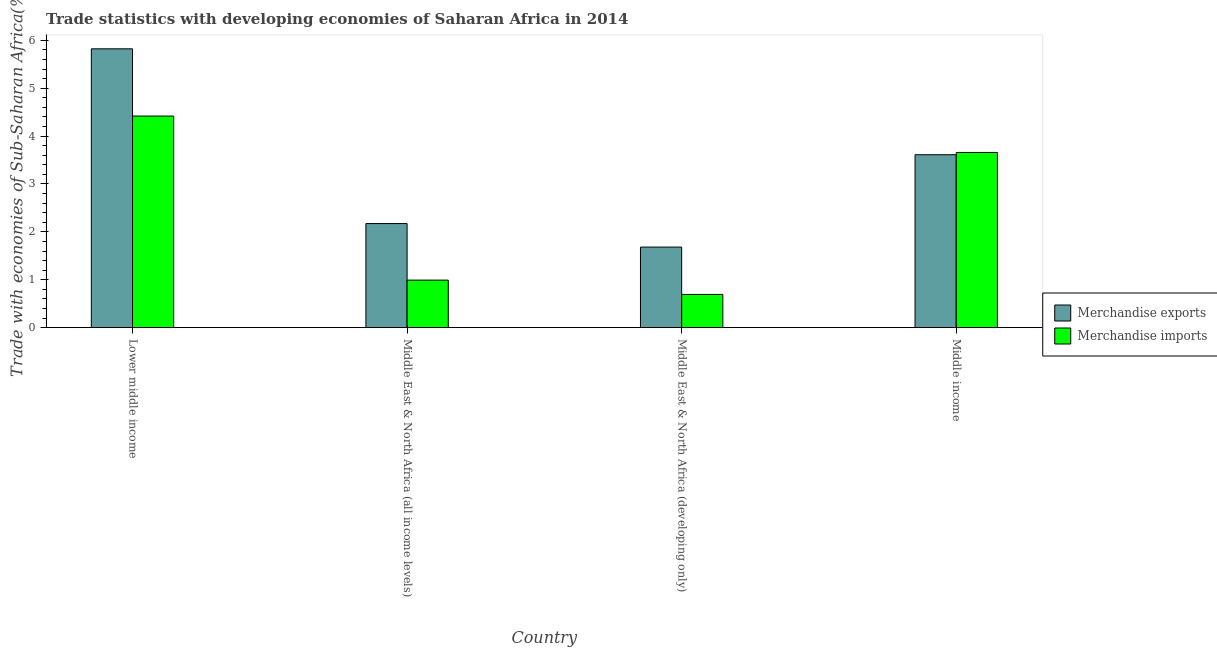How many different coloured bars are there?
Your response must be concise. 2. Are the number of bars per tick equal to the number of legend labels?
Ensure brevity in your answer.  Yes. How many bars are there on the 4th tick from the left?
Provide a short and direct response. 2. How many bars are there on the 4th tick from the right?
Keep it short and to the point. 2. What is the label of the 3rd group of bars from the left?
Your answer should be very brief. Middle East & North Africa (developing only). What is the merchandise exports in Middle income?
Your answer should be compact. 3.61. Across all countries, what is the maximum merchandise imports?
Make the answer very short. 4.42. Across all countries, what is the minimum merchandise imports?
Provide a succinct answer. 0.69. In which country was the merchandise imports maximum?
Your answer should be very brief. Lower middle income. In which country was the merchandise imports minimum?
Keep it short and to the point. Middle East & North Africa (developing only). What is the total merchandise exports in the graph?
Your answer should be compact. 13.29. What is the difference between the merchandise imports in Middle East & North Africa (all income levels) and that in Middle East & North Africa (developing only)?
Your response must be concise. 0.3. What is the difference between the merchandise exports in Lower middle income and the merchandise imports in Middle East & North Africa (developing only)?
Your answer should be very brief. 5.13. What is the average merchandise imports per country?
Offer a terse response. 2.44. What is the difference between the merchandise imports and merchandise exports in Middle East & North Africa (developing only)?
Make the answer very short. -0.99. In how many countries, is the merchandise exports greater than 0.2 %?
Provide a succinct answer. 4. What is the ratio of the merchandise imports in Middle East & North Africa (all income levels) to that in Middle East & North Africa (developing only)?
Offer a terse response. 1.43. What is the difference between the highest and the second highest merchandise imports?
Keep it short and to the point. 0.76. What is the difference between the highest and the lowest merchandise imports?
Offer a very short reply. 3.72. What does the 2nd bar from the left in Middle East & North Africa (developing only) represents?
Your answer should be very brief. Merchandise imports. What does the 2nd bar from the right in Middle East & North Africa (all income levels) represents?
Your response must be concise. Merchandise exports. How many bars are there?
Your answer should be compact. 8. Are all the bars in the graph horizontal?
Ensure brevity in your answer.  No. How many countries are there in the graph?
Give a very brief answer. 4. What is the difference between two consecutive major ticks on the Y-axis?
Provide a short and direct response. 1. Does the graph contain any zero values?
Your answer should be compact. No. Does the graph contain grids?
Make the answer very short. No. Where does the legend appear in the graph?
Ensure brevity in your answer.  Center right. How many legend labels are there?
Give a very brief answer. 2. How are the legend labels stacked?
Offer a terse response. Vertical. What is the title of the graph?
Give a very brief answer. Trade statistics with developing economies of Saharan Africa in 2014. Does "Fraud firms" appear as one of the legend labels in the graph?
Give a very brief answer. No. What is the label or title of the Y-axis?
Keep it short and to the point. Trade with economies of Sub-Saharan Africa(%). What is the Trade with economies of Sub-Saharan Africa(%) in Merchandise exports in Lower middle income?
Provide a short and direct response. 5.82. What is the Trade with economies of Sub-Saharan Africa(%) in Merchandise imports in Lower middle income?
Your response must be concise. 4.42. What is the Trade with economies of Sub-Saharan Africa(%) of Merchandise exports in Middle East & North Africa (all income levels)?
Offer a very short reply. 2.17. What is the Trade with economies of Sub-Saharan Africa(%) of Merchandise imports in Middle East & North Africa (all income levels)?
Provide a short and direct response. 0.99. What is the Trade with economies of Sub-Saharan Africa(%) in Merchandise exports in Middle East & North Africa (developing only)?
Offer a terse response. 1.68. What is the Trade with economies of Sub-Saharan Africa(%) in Merchandise imports in Middle East & North Africa (developing only)?
Your answer should be very brief. 0.69. What is the Trade with economies of Sub-Saharan Africa(%) of Merchandise exports in Middle income?
Offer a very short reply. 3.61. What is the Trade with economies of Sub-Saharan Africa(%) in Merchandise imports in Middle income?
Give a very brief answer. 3.66. Across all countries, what is the maximum Trade with economies of Sub-Saharan Africa(%) in Merchandise exports?
Your answer should be compact. 5.82. Across all countries, what is the maximum Trade with economies of Sub-Saharan Africa(%) in Merchandise imports?
Make the answer very short. 4.42. Across all countries, what is the minimum Trade with economies of Sub-Saharan Africa(%) in Merchandise exports?
Ensure brevity in your answer.  1.68. Across all countries, what is the minimum Trade with economies of Sub-Saharan Africa(%) of Merchandise imports?
Provide a succinct answer. 0.69. What is the total Trade with economies of Sub-Saharan Africa(%) of Merchandise exports in the graph?
Offer a very short reply. 13.29. What is the total Trade with economies of Sub-Saharan Africa(%) of Merchandise imports in the graph?
Your answer should be compact. 9.76. What is the difference between the Trade with economies of Sub-Saharan Africa(%) in Merchandise exports in Lower middle income and that in Middle East & North Africa (all income levels)?
Give a very brief answer. 3.65. What is the difference between the Trade with economies of Sub-Saharan Africa(%) of Merchandise imports in Lower middle income and that in Middle East & North Africa (all income levels)?
Provide a succinct answer. 3.43. What is the difference between the Trade with economies of Sub-Saharan Africa(%) in Merchandise exports in Lower middle income and that in Middle East & North Africa (developing only)?
Offer a terse response. 4.14. What is the difference between the Trade with economies of Sub-Saharan Africa(%) in Merchandise imports in Lower middle income and that in Middle East & North Africa (developing only)?
Offer a terse response. 3.72. What is the difference between the Trade with economies of Sub-Saharan Africa(%) in Merchandise exports in Lower middle income and that in Middle income?
Ensure brevity in your answer.  2.21. What is the difference between the Trade with economies of Sub-Saharan Africa(%) in Merchandise imports in Lower middle income and that in Middle income?
Provide a short and direct response. 0.76. What is the difference between the Trade with economies of Sub-Saharan Africa(%) of Merchandise exports in Middle East & North Africa (all income levels) and that in Middle East & North Africa (developing only)?
Provide a succinct answer. 0.49. What is the difference between the Trade with economies of Sub-Saharan Africa(%) of Merchandise imports in Middle East & North Africa (all income levels) and that in Middle East & North Africa (developing only)?
Offer a very short reply. 0.3. What is the difference between the Trade with economies of Sub-Saharan Africa(%) in Merchandise exports in Middle East & North Africa (all income levels) and that in Middle income?
Give a very brief answer. -1.44. What is the difference between the Trade with economies of Sub-Saharan Africa(%) in Merchandise imports in Middle East & North Africa (all income levels) and that in Middle income?
Ensure brevity in your answer.  -2.67. What is the difference between the Trade with economies of Sub-Saharan Africa(%) of Merchandise exports in Middle East & North Africa (developing only) and that in Middle income?
Offer a very short reply. -1.93. What is the difference between the Trade with economies of Sub-Saharan Africa(%) of Merchandise imports in Middle East & North Africa (developing only) and that in Middle income?
Make the answer very short. -2.96. What is the difference between the Trade with economies of Sub-Saharan Africa(%) of Merchandise exports in Lower middle income and the Trade with economies of Sub-Saharan Africa(%) of Merchandise imports in Middle East & North Africa (all income levels)?
Give a very brief answer. 4.83. What is the difference between the Trade with economies of Sub-Saharan Africa(%) of Merchandise exports in Lower middle income and the Trade with economies of Sub-Saharan Africa(%) of Merchandise imports in Middle East & North Africa (developing only)?
Provide a short and direct response. 5.13. What is the difference between the Trade with economies of Sub-Saharan Africa(%) in Merchandise exports in Lower middle income and the Trade with economies of Sub-Saharan Africa(%) in Merchandise imports in Middle income?
Keep it short and to the point. 2.16. What is the difference between the Trade with economies of Sub-Saharan Africa(%) in Merchandise exports in Middle East & North Africa (all income levels) and the Trade with economies of Sub-Saharan Africa(%) in Merchandise imports in Middle East & North Africa (developing only)?
Keep it short and to the point. 1.48. What is the difference between the Trade with economies of Sub-Saharan Africa(%) of Merchandise exports in Middle East & North Africa (all income levels) and the Trade with economies of Sub-Saharan Africa(%) of Merchandise imports in Middle income?
Your answer should be compact. -1.48. What is the difference between the Trade with economies of Sub-Saharan Africa(%) in Merchandise exports in Middle East & North Africa (developing only) and the Trade with economies of Sub-Saharan Africa(%) in Merchandise imports in Middle income?
Your response must be concise. -1.98. What is the average Trade with economies of Sub-Saharan Africa(%) in Merchandise exports per country?
Offer a terse response. 3.32. What is the average Trade with economies of Sub-Saharan Africa(%) in Merchandise imports per country?
Make the answer very short. 2.44. What is the difference between the Trade with economies of Sub-Saharan Africa(%) in Merchandise exports and Trade with economies of Sub-Saharan Africa(%) in Merchandise imports in Lower middle income?
Your response must be concise. 1.4. What is the difference between the Trade with economies of Sub-Saharan Africa(%) of Merchandise exports and Trade with economies of Sub-Saharan Africa(%) of Merchandise imports in Middle East & North Africa (all income levels)?
Your answer should be very brief. 1.18. What is the difference between the Trade with economies of Sub-Saharan Africa(%) in Merchandise exports and Trade with economies of Sub-Saharan Africa(%) in Merchandise imports in Middle East & North Africa (developing only)?
Offer a very short reply. 0.99. What is the difference between the Trade with economies of Sub-Saharan Africa(%) of Merchandise exports and Trade with economies of Sub-Saharan Africa(%) of Merchandise imports in Middle income?
Provide a short and direct response. -0.05. What is the ratio of the Trade with economies of Sub-Saharan Africa(%) of Merchandise exports in Lower middle income to that in Middle East & North Africa (all income levels)?
Make the answer very short. 2.68. What is the ratio of the Trade with economies of Sub-Saharan Africa(%) in Merchandise imports in Lower middle income to that in Middle East & North Africa (all income levels)?
Your response must be concise. 4.45. What is the ratio of the Trade with economies of Sub-Saharan Africa(%) of Merchandise exports in Lower middle income to that in Middle East & North Africa (developing only)?
Your answer should be compact. 3.46. What is the ratio of the Trade with economies of Sub-Saharan Africa(%) of Merchandise imports in Lower middle income to that in Middle East & North Africa (developing only)?
Your answer should be compact. 6.37. What is the ratio of the Trade with economies of Sub-Saharan Africa(%) in Merchandise exports in Lower middle income to that in Middle income?
Provide a succinct answer. 1.61. What is the ratio of the Trade with economies of Sub-Saharan Africa(%) of Merchandise imports in Lower middle income to that in Middle income?
Provide a succinct answer. 1.21. What is the ratio of the Trade with economies of Sub-Saharan Africa(%) of Merchandise exports in Middle East & North Africa (all income levels) to that in Middle East & North Africa (developing only)?
Ensure brevity in your answer.  1.29. What is the ratio of the Trade with economies of Sub-Saharan Africa(%) of Merchandise imports in Middle East & North Africa (all income levels) to that in Middle East & North Africa (developing only)?
Ensure brevity in your answer.  1.43. What is the ratio of the Trade with economies of Sub-Saharan Africa(%) in Merchandise exports in Middle East & North Africa (all income levels) to that in Middle income?
Your response must be concise. 0.6. What is the ratio of the Trade with economies of Sub-Saharan Africa(%) of Merchandise imports in Middle East & North Africa (all income levels) to that in Middle income?
Offer a terse response. 0.27. What is the ratio of the Trade with economies of Sub-Saharan Africa(%) in Merchandise exports in Middle East & North Africa (developing only) to that in Middle income?
Offer a terse response. 0.47. What is the ratio of the Trade with economies of Sub-Saharan Africa(%) in Merchandise imports in Middle East & North Africa (developing only) to that in Middle income?
Offer a terse response. 0.19. What is the difference between the highest and the second highest Trade with economies of Sub-Saharan Africa(%) of Merchandise exports?
Provide a succinct answer. 2.21. What is the difference between the highest and the second highest Trade with economies of Sub-Saharan Africa(%) in Merchandise imports?
Offer a very short reply. 0.76. What is the difference between the highest and the lowest Trade with economies of Sub-Saharan Africa(%) in Merchandise exports?
Provide a short and direct response. 4.14. What is the difference between the highest and the lowest Trade with economies of Sub-Saharan Africa(%) of Merchandise imports?
Provide a succinct answer. 3.72. 